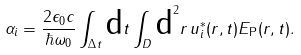<formula> <loc_0><loc_0><loc_500><loc_500>\alpha _ { i } = \frac { 2 \epsilon _ { 0 } c } { \hbar { \omega } _ { 0 } } \int _ { \Delta t } \text {d} t \int _ { D } \text {d} ^ { 2 } { r } \, { u } _ { i } ^ { \ast } ( { r } , t ) { E } _ { \text {P} } ( { r } , t ) .</formula> 